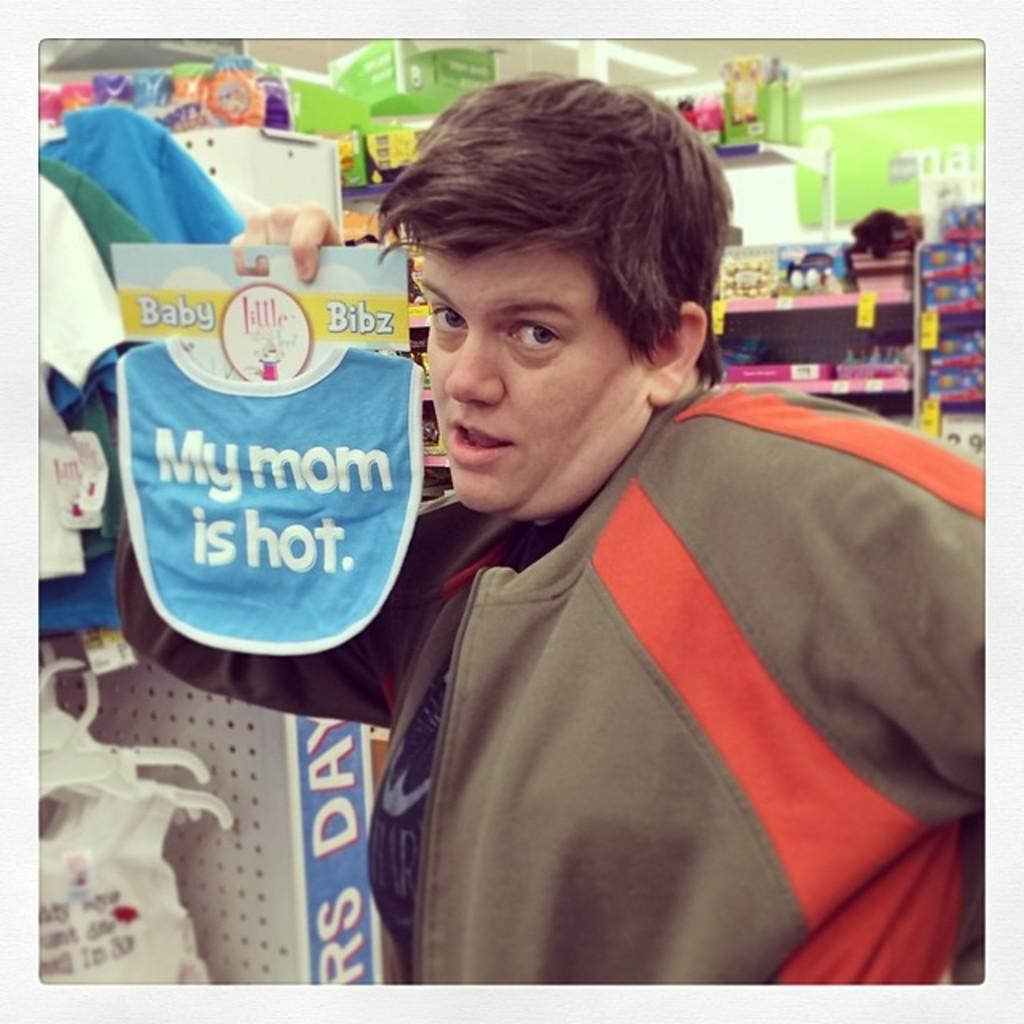<image>
Provide a brief description of the given image. a person holding a sign that says their mom is hot 